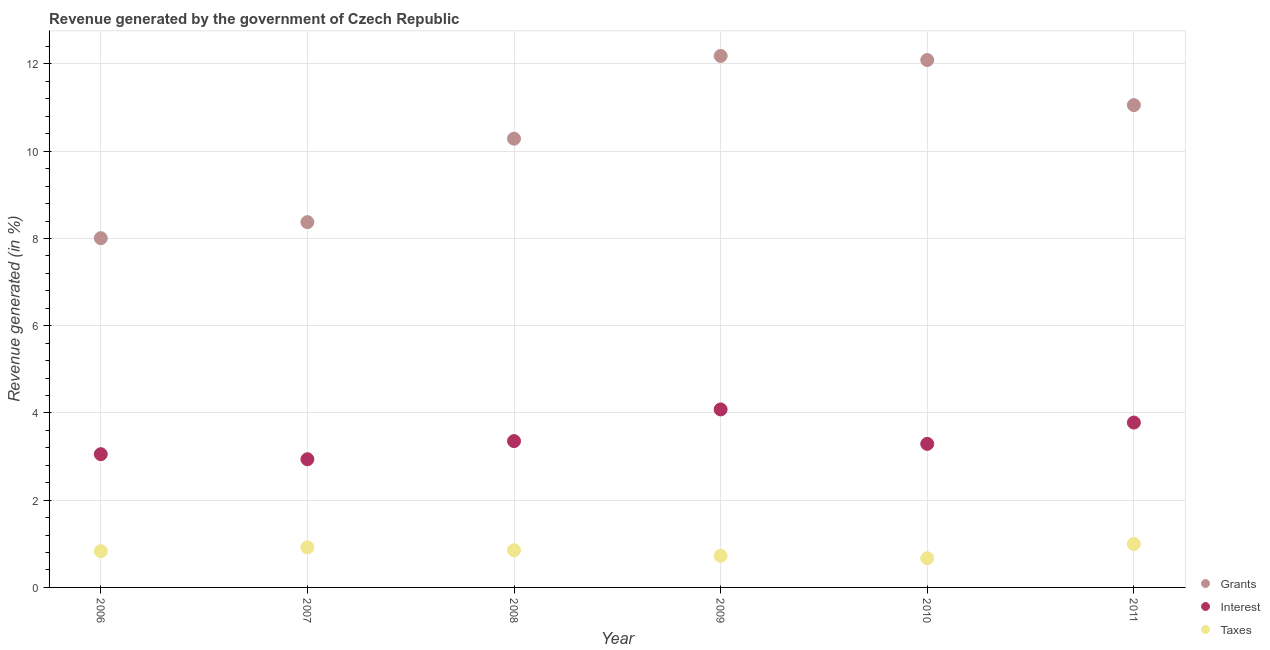How many different coloured dotlines are there?
Offer a very short reply. 3. Is the number of dotlines equal to the number of legend labels?
Your answer should be compact. Yes. What is the percentage of revenue generated by interest in 2008?
Provide a short and direct response. 3.35. Across all years, what is the maximum percentage of revenue generated by grants?
Offer a very short reply. 12.18. Across all years, what is the minimum percentage of revenue generated by interest?
Offer a very short reply. 2.94. In which year was the percentage of revenue generated by grants maximum?
Provide a succinct answer. 2009. What is the total percentage of revenue generated by interest in the graph?
Provide a short and direct response. 20.5. What is the difference between the percentage of revenue generated by interest in 2009 and that in 2011?
Give a very brief answer. 0.3. What is the difference between the percentage of revenue generated by taxes in 2007 and the percentage of revenue generated by interest in 2006?
Provide a short and direct response. -2.14. What is the average percentage of revenue generated by taxes per year?
Offer a terse response. 0.83. In the year 2006, what is the difference between the percentage of revenue generated by interest and percentage of revenue generated by taxes?
Offer a very short reply. 2.22. What is the ratio of the percentage of revenue generated by grants in 2006 to that in 2011?
Keep it short and to the point. 0.72. What is the difference between the highest and the second highest percentage of revenue generated by taxes?
Make the answer very short. 0.08. What is the difference between the highest and the lowest percentage of revenue generated by taxes?
Keep it short and to the point. 0.33. In how many years, is the percentage of revenue generated by interest greater than the average percentage of revenue generated by interest taken over all years?
Your response must be concise. 2. Is the sum of the percentage of revenue generated by taxes in 2006 and 2009 greater than the maximum percentage of revenue generated by grants across all years?
Give a very brief answer. No. Is the percentage of revenue generated by taxes strictly greater than the percentage of revenue generated by grants over the years?
Make the answer very short. No. Is the percentage of revenue generated by taxes strictly less than the percentage of revenue generated by interest over the years?
Ensure brevity in your answer.  Yes. What is the difference between two consecutive major ticks on the Y-axis?
Your response must be concise. 2. Are the values on the major ticks of Y-axis written in scientific E-notation?
Make the answer very short. No. Does the graph contain grids?
Ensure brevity in your answer.  Yes. Where does the legend appear in the graph?
Keep it short and to the point. Bottom right. How many legend labels are there?
Offer a very short reply. 3. What is the title of the graph?
Provide a short and direct response. Revenue generated by the government of Czech Republic. What is the label or title of the X-axis?
Provide a succinct answer. Year. What is the label or title of the Y-axis?
Make the answer very short. Revenue generated (in %). What is the Revenue generated (in %) in Grants in 2006?
Offer a very short reply. 8.01. What is the Revenue generated (in %) in Interest in 2006?
Your response must be concise. 3.05. What is the Revenue generated (in %) in Taxes in 2006?
Give a very brief answer. 0.83. What is the Revenue generated (in %) of Grants in 2007?
Provide a succinct answer. 8.37. What is the Revenue generated (in %) of Interest in 2007?
Your answer should be very brief. 2.94. What is the Revenue generated (in %) in Taxes in 2007?
Your answer should be very brief. 0.92. What is the Revenue generated (in %) of Grants in 2008?
Your answer should be very brief. 10.29. What is the Revenue generated (in %) in Interest in 2008?
Your answer should be very brief. 3.35. What is the Revenue generated (in %) in Taxes in 2008?
Ensure brevity in your answer.  0.85. What is the Revenue generated (in %) in Grants in 2009?
Make the answer very short. 12.18. What is the Revenue generated (in %) of Interest in 2009?
Ensure brevity in your answer.  4.08. What is the Revenue generated (in %) of Taxes in 2009?
Make the answer very short. 0.73. What is the Revenue generated (in %) of Grants in 2010?
Give a very brief answer. 12.09. What is the Revenue generated (in %) of Interest in 2010?
Give a very brief answer. 3.29. What is the Revenue generated (in %) of Taxes in 2010?
Ensure brevity in your answer.  0.67. What is the Revenue generated (in %) in Grants in 2011?
Your answer should be very brief. 11.06. What is the Revenue generated (in %) in Interest in 2011?
Provide a succinct answer. 3.78. What is the Revenue generated (in %) in Taxes in 2011?
Keep it short and to the point. 1. Across all years, what is the maximum Revenue generated (in %) in Grants?
Provide a short and direct response. 12.18. Across all years, what is the maximum Revenue generated (in %) of Interest?
Offer a terse response. 4.08. Across all years, what is the maximum Revenue generated (in %) in Taxes?
Provide a succinct answer. 1. Across all years, what is the minimum Revenue generated (in %) of Grants?
Provide a succinct answer. 8.01. Across all years, what is the minimum Revenue generated (in %) in Interest?
Keep it short and to the point. 2.94. Across all years, what is the minimum Revenue generated (in %) of Taxes?
Keep it short and to the point. 0.67. What is the total Revenue generated (in %) in Grants in the graph?
Keep it short and to the point. 62. What is the total Revenue generated (in %) in Interest in the graph?
Provide a short and direct response. 20.5. What is the total Revenue generated (in %) in Taxes in the graph?
Provide a succinct answer. 4.99. What is the difference between the Revenue generated (in %) in Grants in 2006 and that in 2007?
Provide a succinct answer. -0.37. What is the difference between the Revenue generated (in %) of Interest in 2006 and that in 2007?
Offer a terse response. 0.12. What is the difference between the Revenue generated (in %) in Taxes in 2006 and that in 2007?
Your answer should be very brief. -0.09. What is the difference between the Revenue generated (in %) in Grants in 2006 and that in 2008?
Your answer should be compact. -2.28. What is the difference between the Revenue generated (in %) of Interest in 2006 and that in 2008?
Offer a terse response. -0.3. What is the difference between the Revenue generated (in %) in Taxes in 2006 and that in 2008?
Ensure brevity in your answer.  -0.02. What is the difference between the Revenue generated (in %) of Grants in 2006 and that in 2009?
Your answer should be very brief. -4.18. What is the difference between the Revenue generated (in %) of Interest in 2006 and that in 2009?
Ensure brevity in your answer.  -1.03. What is the difference between the Revenue generated (in %) of Taxes in 2006 and that in 2009?
Make the answer very short. 0.11. What is the difference between the Revenue generated (in %) in Grants in 2006 and that in 2010?
Offer a very short reply. -4.08. What is the difference between the Revenue generated (in %) of Interest in 2006 and that in 2010?
Offer a very short reply. -0.24. What is the difference between the Revenue generated (in %) of Taxes in 2006 and that in 2010?
Offer a very short reply. 0.16. What is the difference between the Revenue generated (in %) of Grants in 2006 and that in 2011?
Offer a very short reply. -3.05. What is the difference between the Revenue generated (in %) of Interest in 2006 and that in 2011?
Your answer should be very brief. -0.72. What is the difference between the Revenue generated (in %) of Taxes in 2006 and that in 2011?
Offer a terse response. -0.17. What is the difference between the Revenue generated (in %) of Grants in 2007 and that in 2008?
Offer a terse response. -1.91. What is the difference between the Revenue generated (in %) in Interest in 2007 and that in 2008?
Ensure brevity in your answer.  -0.42. What is the difference between the Revenue generated (in %) in Taxes in 2007 and that in 2008?
Offer a very short reply. 0.06. What is the difference between the Revenue generated (in %) of Grants in 2007 and that in 2009?
Your response must be concise. -3.81. What is the difference between the Revenue generated (in %) of Interest in 2007 and that in 2009?
Your answer should be very brief. -1.14. What is the difference between the Revenue generated (in %) in Taxes in 2007 and that in 2009?
Your response must be concise. 0.19. What is the difference between the Revenue generated (in %) in Grants in 2007 and that in 2010?
Give a very brief answer. -3.72. What is the difference between the Revenue generated (in %) of Interest in 2007 and that in 2010?
Your answer should be compact. -0.35. What is the difference between the Revenue generated (in %) in Taxes in 2007 and that in 2010?
Your answer should be very brief. 0.25. What is the difference between the Revenue generated (in %) in Grants in 2007 and that in 2011?
Your answer should be compact. -2.68. What is the difference between the Revenue generated (in %) in Interest in 2007 and that in 2011?
Your answer should be compact. -0.84. What is the difference between the Revenue generated (in %) in Taxes in 2007 and that in 2011?
Your response must be concise. -0.08. What is the difference between the Revenue generated (in %) of Grants in 2008 and that in 2009?
Keep it short and to the point. -1.9. What is the difference between the Revenue generated (in %) in Interest in 2008 and that in 2009?
Your answer should be compact. -0.73. What is the difference between the Revenue generated (in %) in Taxes in 2008 and that in 2009?
Give a very brief answer. 0.13. What is the difference between the Revenue generated (in %) in Grants in 2008 and that in 2010?
Provide a short and direct response. -1.8. What is the difference between the Revenue generated (in %) of Interest in 2008 and that in 2010?
Give a very brief answer. 0.06. What is the difference between the Revenue generated (in %) of Taxes in 2008 and that in 2010?
Give a very brief answer. 0.18. What is the difference between the Revenue generated (in %) in Grants in 2008 and that in 2011?
Your answer should be compact. -0.77. What is the difference between the Revenue generated (in %) of Interest in 2008 and that in 2011?
Offer a very short reply. -0.43. What is the difference between the Revenue generated (in %) in Taxes in 2008 and that in 2011?
Make the answer very short. -0.14. What is the difference between the Revenue generated (in %) in Grants in 2009 and that in 2010?
Provide a short and direct response. 0.09. What is the difference between the Revenue generated (in %) of Interest in 2009 and that in 2010?
Your response must be concise. 0.79. What is the difference between the Revenue generated (in %) in Taxes in 2009 and that in 2010?
Your response must be concise. 0.06. What is the difference between the Revenue generated (in %) in Grants in 2009 and that in 2011?
Your answer should be compact. 1.13. What is the difference between the Revenue generated (in %) in Interest in 2009 and that in 2011?
Ensure brevity in your answer.  0.3. What is the difference between the Revenue generated (in %) in Taxes in 2009 and that in 2011?
Provide a short and direct response. -0.27. What is the difference between the Revenue generated (in %) in Grants in 2010 and that in 2011?
Provide a short and direct response. 1.03. What is the difference between the Revenue generated (in %) in Interest in 2010 and that in 2011?
Make the answer very short. -0.49. What is the difference between the Revenue generated (in %) of Taxes in 2010 and that in 2011?
Your answer should be compact. -0.33. What is the difference between the Revenue generated (in %) of Grants in 2006 and the Revenue generated (in %) of Interest in 2007?
Provide a short and direct response. 5.07. What is the difference between the Revenue generated (in %) in Grants in 2006 and the Revenue generated (in %) in Taxes in 2007?
Offer a very short reply. 7.09. What is the difference between the Revenue generated (in %) in Interest in 2006 and the Revenue generated (in %) in Taxes in 2007?
Your answer should be very brief. 2.14. What is the difference between the Revenue generated (in %) of Grants in 2006 and the Revenue generated (in %) of Interest in 2008?
Offer a very short reply. 4.65. What is the difference between the Revenue generated (in %) in Grants in 2006 and the Revenue generated (in %) in Taxes in 2008?
Provide a succinct answer. 7.15. What is the difference between the Revenue generated (in %) of Interest in 2006 and the Revenue generated (in %) of Taxes in 2008?
Provide a succinct answer. 2.2. What is the difference between the Revenue generated (in %) of Grants in 2006 and the Revenue generated (in %) of Interest in 2009?
Make the answer very short. 3.93. What is the difference between the Revenue generated (in %) of Grants in 2006 and the Revenue generated (in %) of Taxes in 2009?
Make the answer very short. 7.28. What is the difference between the Revenue generated (in %) of Interest in 2006 and the Revenue generated (in %) of Taxes in 2009?
Your response must be concise. 2.33. What is the difference between the Revenue generated (in %) of Grants in 2006 and the Revenue generated (in %) of Interest in 2010?
Provide a short and direct response. 4.72. What is the difference between the Revenue generated (in %) of Grants in 2006 and the Revenue generated (in %) of Taxes in 2010?
Make the answer very short. 7.34. What is the difference between the Revenue generated (in %) in Interest in 2006 and the Revenue generated (in %) in Taxes in 2010?
Your answer should be compact. 2.39. What is the difference between the Revenue generated (in %) of Grants in 2006 and the Revenue generated (in %) of Interest in 2011?
Provide a succinct answer. 4.23. What is the difference between the Revenue generated (in %) of Grants in 2006 and the Revenue generated (in %) of Taxes in 2011?
Make the answer very short. 7.01. What is the difference between the Revenue generated (in %) of Interest in 2006 and the Revenue generated (in %) of Taxes in 2011?
Provide a succinct answer. 2.06. What is the difference between the Revenue generated (in %) of Grants in 2007 and the Revenue generated (in %) of Interest in 2008?
Provide a succinct answer. 5.02. What is the difference between the Revenue generated (in %) in Grants in 2007 and the Revenue generated (in %) in Taxes in 2008?
Give a very brief answer. 7.52. What is the difference between the Revenue generated (in %) of Interest in 2007 and the Revenue generated (in %) of Taxes in 2008?
Ensure brevity in your answer.  2.09. What is the difference between the Revenue generated (in %) of Grants in 2007 and the Revenue generated (in %) of Interest in 2009?
Provide a succinct answer. 4.29. What is the difference between the Revenue generated (in %) in Grants in 2007 and the Revenue generated (in %) in Taxes in 2009?
Ensure brevity in your answer.  7.65. What is the difference between the Revenue generated (in %) in Interest in 2007 and the Revenue generated (in %) in Taxes in 2009?
Your response must be concise. 2.21. What is the difference between the Revenue generated (in %) in Grants in 2007 and the Revenue generated (in %) in Interest in 2010?
Give a very brief answer. 5.08. What is the difference between the Revenue generated (in %) of Grants in 2007 and the Revenue generated (in %) of Taxes in 2010?
Your answer should be very brief. 7.71. What is the difference between the Revenue generated (in %) in Interest in 2007 and the Revenue generated (in %) in Taxes in 2010?
Provide a succinct answer. 2.27. What is the difference between the Revenue generated (in %) in Grants in 2007 and the Revenue generated (in %) in Interest in 2011?
Offer a very short reply. 4.59. What is the difference between the Revenue generated (in %) of Grants in 2007 and the Revenue generated (in %) of Taxes in 2011?
Keep it short and to the point. 7.38. What is the difference between the Revenue generated (in %) in Interest in 2007 and the Revenue generated (in %) in Taxes in 2011?
Your answer should be very brief. 1.94. What is the difference between the Revenue generated (in %) in Grants in 2008 and the Revenue generated (in %) in Interest in 2009?
Provide a short and direct response. 6.21. What is the difference between the Revenue generated (in %) of Grants in 2008 and the Revenue generated (in %) of Taxes in 2009?
Provide a short and direct response. 9.56. What is the difference between the Revenue generated (in %) of Interest in 2008 and the Revenue generated (in %) of Taxes in 2009?
Offer a very short reply. 2.63. What is the difference between the Revenue generated (in %) of Grants in 2008 and the Revenue generated (in %) of Interest in 2010?
Provide a succinct answer. 7. What is the difference between the Revenue generated (in %) of Grants in 2008 and the Revenue generated (in %) of Taxes in 2010?
Your answer should be very brief. 9.62. What is the difference between the Revenue generated (in %) of Interest in 2008 and the Revenue generated (in %) of Taxes in 2010?
Provide a succinct answer. 2.69. What is the difference between the Revenue generated (in %) in Grants in 2008 and the Revenue generated (in %) in Interest in 2011?
Provide a succinct answer. 6.51. What is the difference between the Revenue generated (in %) in Grants in 2008 and the Revenue generated (in %) in Taxes in 2011?
Provide a short and direct response. 9.29. What is the difference between the Revenue generated (in %) of Interest in 2008 and the Revenue generated (in %) of Taxes in 2011?
Ensure brevity in your answer.  2.36. What is the difference between the Revenue generated (in %) in Grants in 2009 and the Revenue generated (in %) in Interest in 2010?
Ensure brevity in your answer.  8.89. What is the difference between the Revenue generated (in %) in Grants in 2009 and the Revenue generated (in %) in Taxes in 2010?
Keep it short and to the point. 11.52. What is the difference between the Revenue generated (in %) of Interest in 2009 and the Revenue generated (in %) of Taxes in 2010?
Ensure brevity in your answer.  3.41. What is the difference between the Revenue generated (in %) of Grants in 2009 and the Revenue generated (in %) of Interest in 2011?
Give a very brief answer. 8.4. What is the difference between the Revenue generated (in %) in Grants in 2009 and the Revenue generated (in %) in Taxes in 2011?
Give a very brief answer. 11.19. What is the difference between the Revenue generated (in %) of Interest in 2009 and the Revenue generated (in %) of Taxes in 2011?
Your response must be concise. 3.08. What is the difference between the Revenue generated (in %) of Grants in 2010 and the Revenue generated (in %) of Interest in 2011?
Your response must be concise. 8.31. What is the difference between the Revenue generated (in %) of Grants in 2010 and the Revenue generated (in %) of Taxes in 2011?
Your answer should be compact. 11.1. What is the difference between the Revenue generated (in %) of Interest in 2010 and the Revenue generated (in %) of Taxes in 2011?
Offer a terse response. 2.3. What is the average Revenue generated (in %) of Grants per year?
Keep it short and to the point. 10.33. What is the average Revenue generated (in %) of Interest per year?
Offer a very short reply. 3.42. What is the average Revenue generated (in %) of Taxes per year?
Your answer should be very brief. 0.83. In the year 2006, what is the difference between the Revenue generated (in %) in Grants and Revenue generated (in %) in Interest?
Offer a terse response. 4.95. In the year 2006, what is the difference between the Revenue generated (in %) of Grants and Revenue generated (in %) of Taxes?
Ensure brevity in your answer.  7.18. In the year 2006, what is the difference between the Revenue generated (in %) of Interest and Revenue generated (in %) of Taxes?
Keep it short and to the point. 2.22. In the year 2007, what is the difference between the Revenue generated (in %) of Grants and Revenue generated (in %) of Interest?
Make the answer very short. 5.44. In the year 2007, what is the difference between the Revenue generated (in %) in Grants and Revenue generated (in %) in Taxes?
Keep it short and to the point. 7.46. In the year 2007, what is the difference between the Revenue generated (in %) in Interest and Revenue generated (in %) in Taxes?
Your response must be concise. 2.02. In the year 2008, what is the difference between the Revenue generated (in %) of Grants and Revenue generated (in %) of Interest?
Offer a very short reply. 6.93. In the year 2008, what is the difference between the Revenue generated (in %) in Grants and Revenue generated (in %) in Taxes?
Your answer should be very brief. 9.43. In the year 2008, what is the difference between the Revenue generated (in %) in Interest and Revenue generated (in %) in Taxes?
Provide a succinct answer. 2.5. In the year 2009, what is the difference between the Revenue generated (in %) of Grants and Revenue generated (in %) of Interest?
Your answer should be compact. 8.1. In the year 2009, what is the difference between the Revenue generated (in %) in Grants and Revenue generated (in %) in Taxes?
Provide a short and direct response. 11.46. In the year 2009, what is the difference between the Revenue generated (in %) of Interest and Revenue generated (in %) of Taxes?
Your response must be concise. 3.36. In the year 2010, what is the difference between the Revenue generated (in %) of Grants and Revenue generated (in %) of Interest?
Offer a very short reply. 8.8. In the year 2010, what is the difference between the Revenue generated (in %) in Grants and Revenue generated (in %) in Taxes?
Provide a succinct answer. 11.42. In the year 2010, what is the difference between the Revenue generated (in %) in Interest and Revenue generated (in %) in Taxes?
Provide a succinct answer. 2.62. In the year 2011, what is the difference between the Revenue generated (in %) in Grants and Revenue generated (in %) in Interest?
Provide a succinct answer. 7.28. In the year 2011, what is the difference between the Revenue generated (in %) in Grants and Revenue generated (in %) in Taxes?
Keep it short and to the point. 10.06. In the year 2011, what is the difference between the Revenue generated (in %) in Interest and Revenue generated (in %) in Taxes?
Provide a succinct answer. 2.78. What is the ratio of the Revenue generated (in %) in Grants in 2006 to that in 2007?
Provide a succinct answer. 0.96. What is the ratio of the Revenue generated (in %) of Interest in 2006 to that in 2007?
Provide a short and direct response. 1.04. What is the ratio of the Revenue generated (in %) of Taxes in 2006 to that in 2007?
Provide a succinct answer. 0.91. What is the ratio of the Revenue generated (in %) of Grants in 2006 to that in 2008?
Ensure brevity in your answer.  0.78. What is the ratio of the Revenue generated (in %) of Interest in 2006 to that in 2008?
Provide a short and direct response. 0.91. What is the ratio of the Revenue generated (in %) of Taxes in 2006 to that in 2008?
Provide a succinct answer. 0.97. What is the ratio of the Revenue generated (in %) of Grants in 2006 to that in 2009?
Make the answer very short. 0.66. What is the ratio of the Revenue generated (in %) of Interest in 2006 to that in 2009?
Your answer should be compact. 0.75. What is the ratio of the Revenue generated (in %) of Taxes in 2006 to that in 2009?
Your response must be concise. 1.15. What is the ratio of the Revenue generated (in %) of Grants in 2006 to that in 2010?
Offer a terse response. 0.66. What is the ratio of the Revenue generated (in %) in Interest in 2006 to that in 2010?
Make the answer very short. 0.93. What is the ratio of the Revenue generated (in %) in Taxes in 2006 to that in 2010?
Make the answer very short. 1.24. What is the ratio of the Revenue generated (in %) in Grants in 2006 to that in 2011?
Make the answer very short. 0.72. What is the ratio of the Revenue generated (in %) of Interest in 2006 to that in 2011?
Your answer should be very brief. 0.81. What is the ratio of the Revenue generated (in %) of Taxes in 2006 to that in 2011?
Offer a very short reply. 0.83. What is the ratio of the Revenue generated (in %) in Grants in 2007 to that in 2008?
Your answer should be very brief. 0.81. What is the ratio of the Revenue generated (in %) of Interest in 2007 to that in 2008?
Provide a succinct answer. 0.88. What is the ratio of the Revenue generated (in %) of Taxes in 2007 to that in 2008?
Ensure brevity in your answer.  1.08. What is the ratio of the Revenue generated (in %) in Grants in 2007 to that in 2009?
Your answer should be very brief. 0.69. What is the ratio of the Revenue generated (in %) of Interest in 2007 to that in 2009?
Keep it short and to the point. 0.72. What is the ratio of the Revenue generated (in %) in Taxes in 2007 to that in 2009?
Keep it short and to the point. 1.26. What is the ratio of the Revenue generated (in %) of Grants in 2007 to that in 2010?
Ensure brevity in your answer.  0.69. What is the ratio of the Revenue generated (in %) in Interest in 2007 to that in 2010?
Make the answer very short. 0.89. What is the ratio of the Revenue generated (in %) in Taxes in 2007 to that in 2010?
Offer a very short reply. 1.37. What is the ratio of the Revenue generated (in %) of Grants in 2007 to that in 2011?
Your answer should be very brief. 0.76. What is the ratio of the Revenue generated (in %) of Interest in 2007 to that in 2011?
Keep it short and to the point. 0.78. What is the ratio of the Revenue generated (in %) in Taxes in 2007 to that in 2011?
Make the answer very short. 0.92. What is the ratio of the Revenue generated (in %) in Grants in 2008 to that in 2009?
Provide a succinct answer. 0.84. What is the ratio of the Revenue generated (in %) in Interest in 2008 to that in 2009?
Provide a short and direct response. 0.82. What is the ratio of the Revenue generated (in %) of Taxes in 2008 to that in 2009?
Provide a short and direct response. 1.18. What is the ratio of the Revenue generated (in %) in Grants in 2008 to that in 2010?
Your response must be concise. 0.85. What is the ratio of the Revenue generated (in %) of Interest in 2008 to that in 2010?
Ensure brevity in your answer.  1.02. What is the ratio of the Revenue generated (in %) of Taxes in 2008 to that in 2010?
Ensure brevity in your answer.  1.27. What is the ratio of the Revenue generated (in %) of Grants in 2008 to that in 2011?
Ensure brevity in your answer.  0.93. What is the ratio of the Revenue generated (in %) of Interest in 2008 to that in 2011?
Provide a succinct answer. 0.89. What is the ratio of the Revenue generated (in %) of Taxes in 2008 to that in 2011?
Your answer should be compact. 0.86. What is the ratio of the Revenue generated (in %) of Grants in 2009 to that in 2010?
Provide a succinct answer. 1.01. What is the ratio of the Revenue generated (in %) in Interest in 2009 to that in 2010?
Offer a terse response. 1.24. What is the ratio of the Revenue generated (in %) of Taxes in 2009 to that in 2010?
Ensure brevity in your answer.  1.08. What is the ratio of the Revenue generated (in %) of Grants in 2009 to that in 2011?
Make the answer very short. 1.1. What is the ratio of the Revenue generated (in %) of Interest in 2009 to that in 2011?
Offer a terse response. 1.08. What is the ratio of the Revenue generated (in %) in Taxes in 2009 to that in 2011?
Provide a short and direct response. 0.73. What is the ratio of the Revenue generated (in %) of Grants in 2010 to that in 2011?
Provide a short and direct response. 1.09. What is the ratio of the Revenue generated (in %) of Interest in 2010 to that in 2011?
Give a very brief answer. 0.87. What is the ratio of the Revenue generated (in %) of Taxes in 2010 to that in 2011?
Ensure brevity in your answer.  0.67. What is the difference between the highest and the second highest Revenue generated (in %) in Grants?
Keep it short and to the point. 0.09. What is the difference between the highest and the second highest Revenue generated (in %) in Interest?
Keep it short and to the point. 0.3. What is the difference between the highest and the second highest Revenue generated (in %) in Taxes?
Your answer should be compact. 0.08. What is the difference between the highest and the lowest Revenue generated (in %) in Grants?
Provide a succinct answer. 4.18. What is the difference between the highest and the lowest Revenue generated (in %) in Interest?
Provide a succinct answer. 1.14. What is the difference between the highest and the lowest Revenue generated (in %) of Taxes?
Your answer should be very brief. 0.33. 